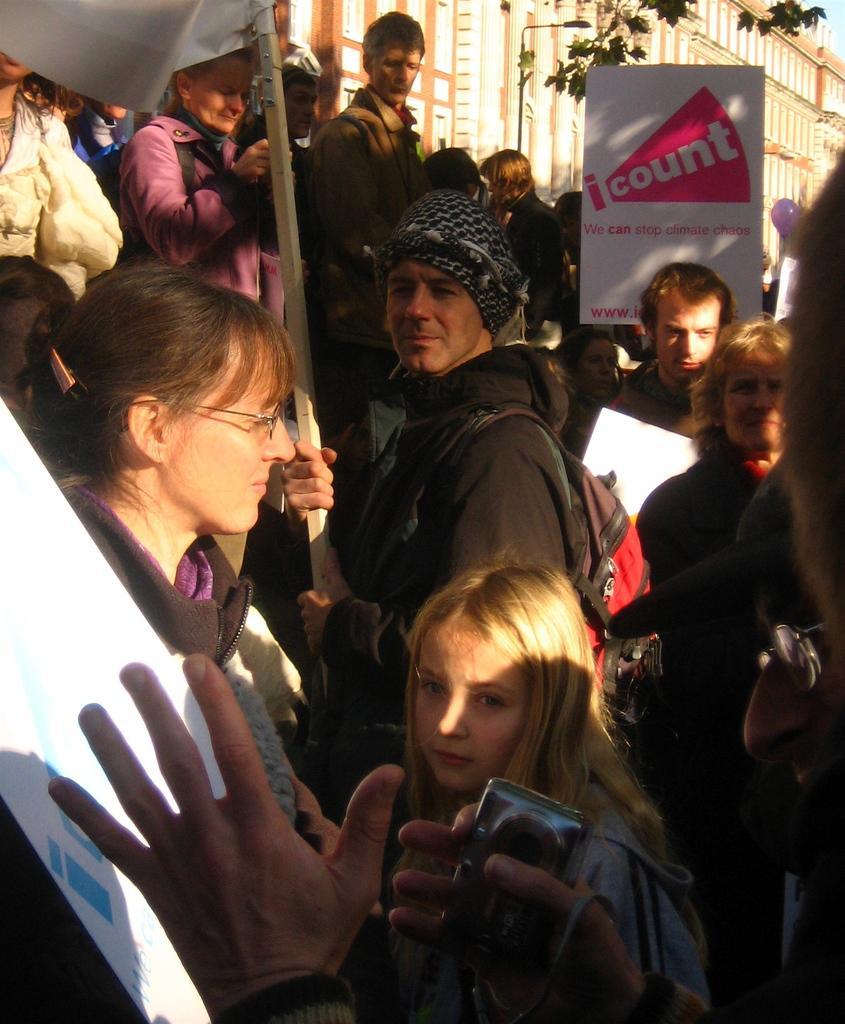Describe this image in one or two sentences. In this image we can see a group of people. Here we can see the hands of a person holding the mobile phone. Here we can see a man holding the pole in his hands. Here we can see the hoarding and a light pole. In the background, we can see the building. 